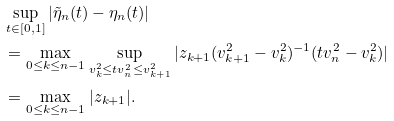<formula> <loc_0><loc_0><loc_500><loc_500>& \sup _ { t \in [ 0 , 1 ] } | \tilde { \eta } _ { n } ( t ) - \eta _ { n } ( t ) | \\ & = \max _ { 0 \leq k \leq n - 1 } \sup _ { v _ { k } ^ { 2 } \leq t v _ { n } ^ { 2 } \leq v _ { k + 1 } ^ { 2 } } | z _ { k + 1 } ( v _ { k + 1 } ^ { 2 } - v _ { k } ^ { 2 } ) ^ { - 1 } ( t v _ { n } ^ { 2 } - v _ { k } ^ { 2 } ) | \\ & = \max _ { 0 \leq k \leq n - 1 } | z _ { k + 1 } | .</formula> 